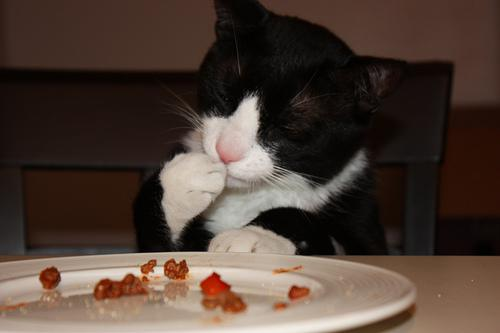Question: why is the cat by the table?
Choices:
A. He saw a mouse.
B. He wants attention.
C. It is eating the food.
D. It is hungry.
Answer with the letter. Answer: C Question: who is in the picture?
Choices:
A. A cat.
B. A dog.
C. A horse.
D. A chicken.
Answer with the letter. Answer: A Question: where is the cat?
Choices:
A. On the bed.
B. In the left corner.
C. In the laundry basket.
D. By a table.
Answer with the letter. Answer: D Question: how much food is on the plate?
Choices:
A. Normal portions.
B. Just crumbs.
C. Very little.
D. Plate is piled high.
Answer with the letter. Answer: C 